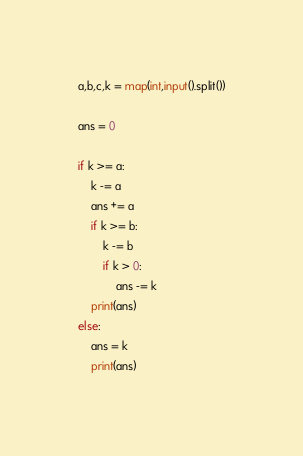<code> <loc_0><loc_0><loc_500><loc_500><_Python_>a,b,c,k = map(int,input().split())

ans = 0

if k >= a:
    k -= a
    ans += a
    if k >= b:
        k -= b
        if k > 0:
            ans -= k
    print(ans)
else:
    ans = k
    print(ans)
</code> 